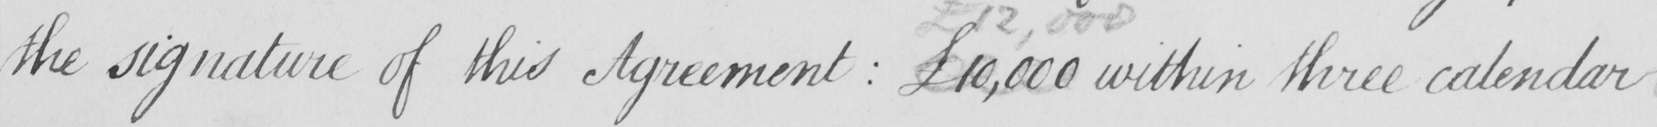Can you tell me what this handwritten text says? the signature of this Agreement  :  £10,000 within three calendar 